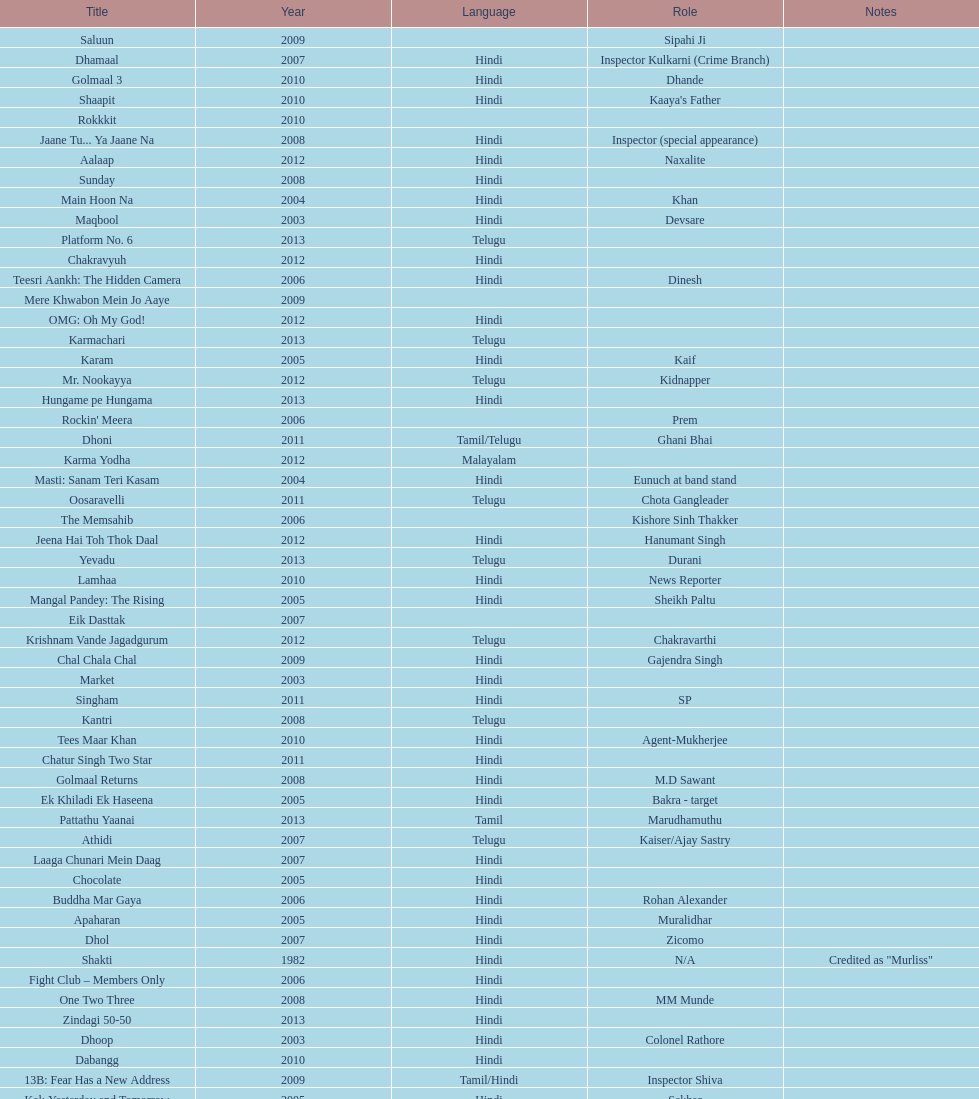What is the total years on the chart 13. 